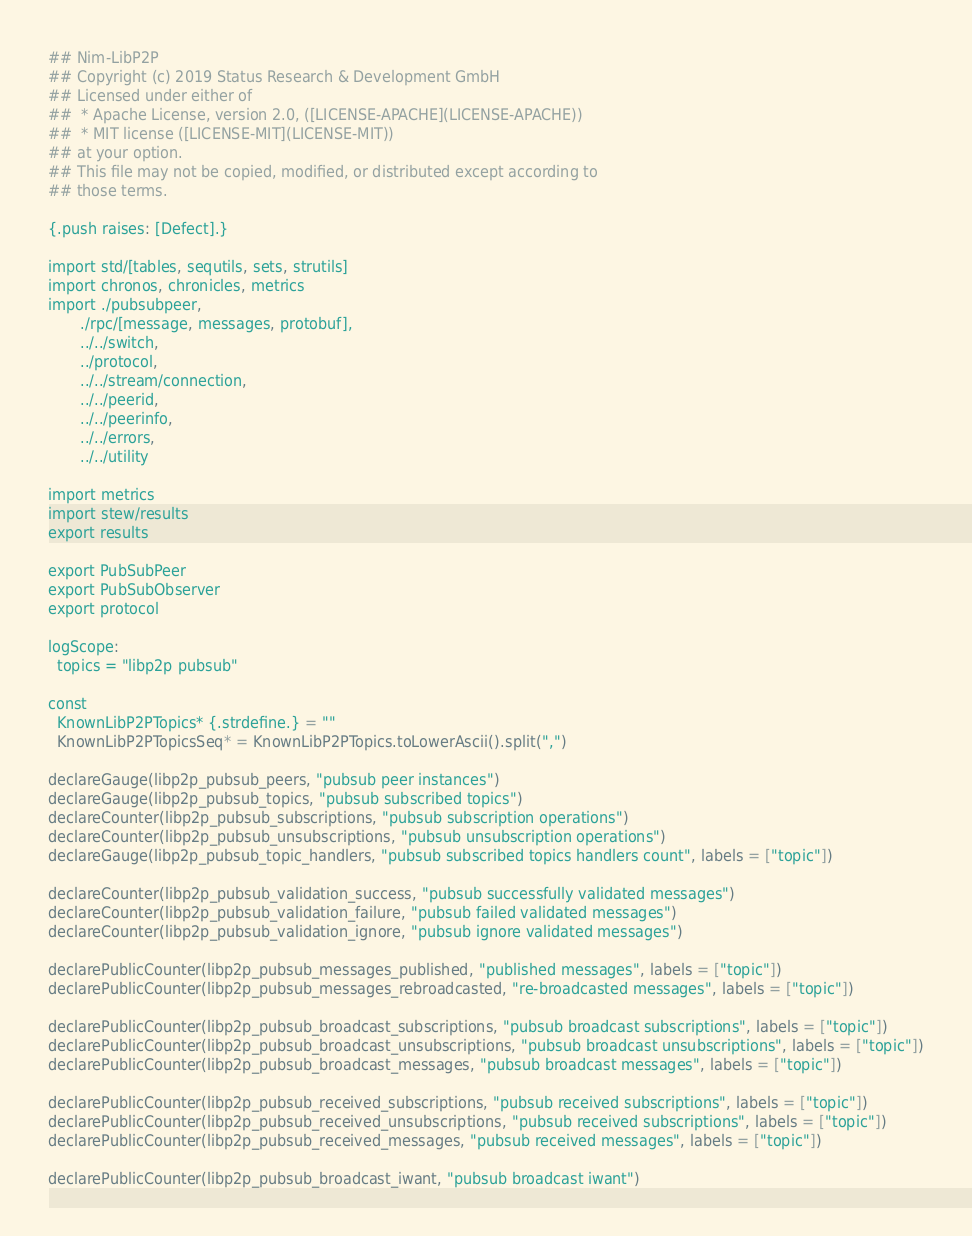<code> <loc_0><loc_0><loc_500><loc_500><_Nim_>## Nim-LibP2P
## Copyright (c) 2019 Status Research & Development GmbH
## Licensed under either of
##  * Apache License, version 2.0, ([LICENSE-APACHE](LICENSE-APACHE))
##  * MIT license ([LICENSE-MIT](LICENSE-MIT))
## at your option.
## This file may not be copied, modified, or distributed except according to
## those terms.

{.push raises: [Defect].}

import std/[tables, sequtils, sets, strutils]
import chronos, chronicles, metrics
import ./pubsubpeer,
       ./rpc/[message, messages, protobuf],
       ../../switch,
       ../protocol,
       ../../stream/connection,
       ../../peerid,
       ../../peerinfo,
       ../../errors,
       ../../utility

import metrics
import stew/results
export results

export PubSubPeer
export PubSubObserver
export protocol

logScope:
  topics = "libp2p pubsub"

const
  KnownLibP2PTopics* {.strdefine.} = ""
  KnownLibP2PTopicsSeq* = KnownLibP2PTopics.toLowerAscii().split(",")

declareGauge(libp2p_pubsub_peers, "pubsub peer instances")
declareGauge(libp2p_pubsub_topics, "pubsub subscribed topics")
declareCounter(libp2p_pubsub_subscriptions, "pubsub subscription operations")
declareCounter(libp2p_pubsub_unsubscriptions, "pubsub unsubscription operations")
declareGauge(libp2p_pubsub_topic_handlers, "pubsub subscribed topics handlers count", labels = ["topic"])

declareCounter(libp2p_pubsub_validation_success, "pubsub successfully validated messages")
declareCounter(libp2p_pubsub_validation_failure, "pubsub failed validated messages")
declareCounter(libp2p_pubsub_validation_ignore, "pubsub ignore validated messages")

declarePublicCounter(libp2p_pubsub_messages_published, "published messages", labels = ["topic"])
declarePublicCounter(libp2p_pubsub_messages_rebroadcasted, "re-broadcasted messages", labels = ["topic"])

declarePublicCounter(libp2p_pubsub_broadcast_subscriptions, "pubsub broadcast subscriptions", labels = ["topic"])
declarePublicCounter(libp2p_pubsub_broadcast_unsubscriptions, "pubsub broadcast unsubscriptions", labels = ["topic"])
declarePublicCounter(libp2p_pubsub_broadcast_messages, "pubsub broadcast messages", labels = ["topic"])

declarePublicCounter(libp2p_pubsub_received_subscriptions, "pubsub received subscriptions", labels = ["topic"])
declarePublicCounter(libp2p_pubsub_received_unsubscriptions, "pubsub received subscriptions", labels = ["topic"])
declarePublicCounter(libp2p_pubsub_received_messages, "pubsub received messages", labels = ["topic"])

declarePublicCounter(libp2p_pubsub_broadcast_iwant, "pubsub broadcast iwant")
</code> 